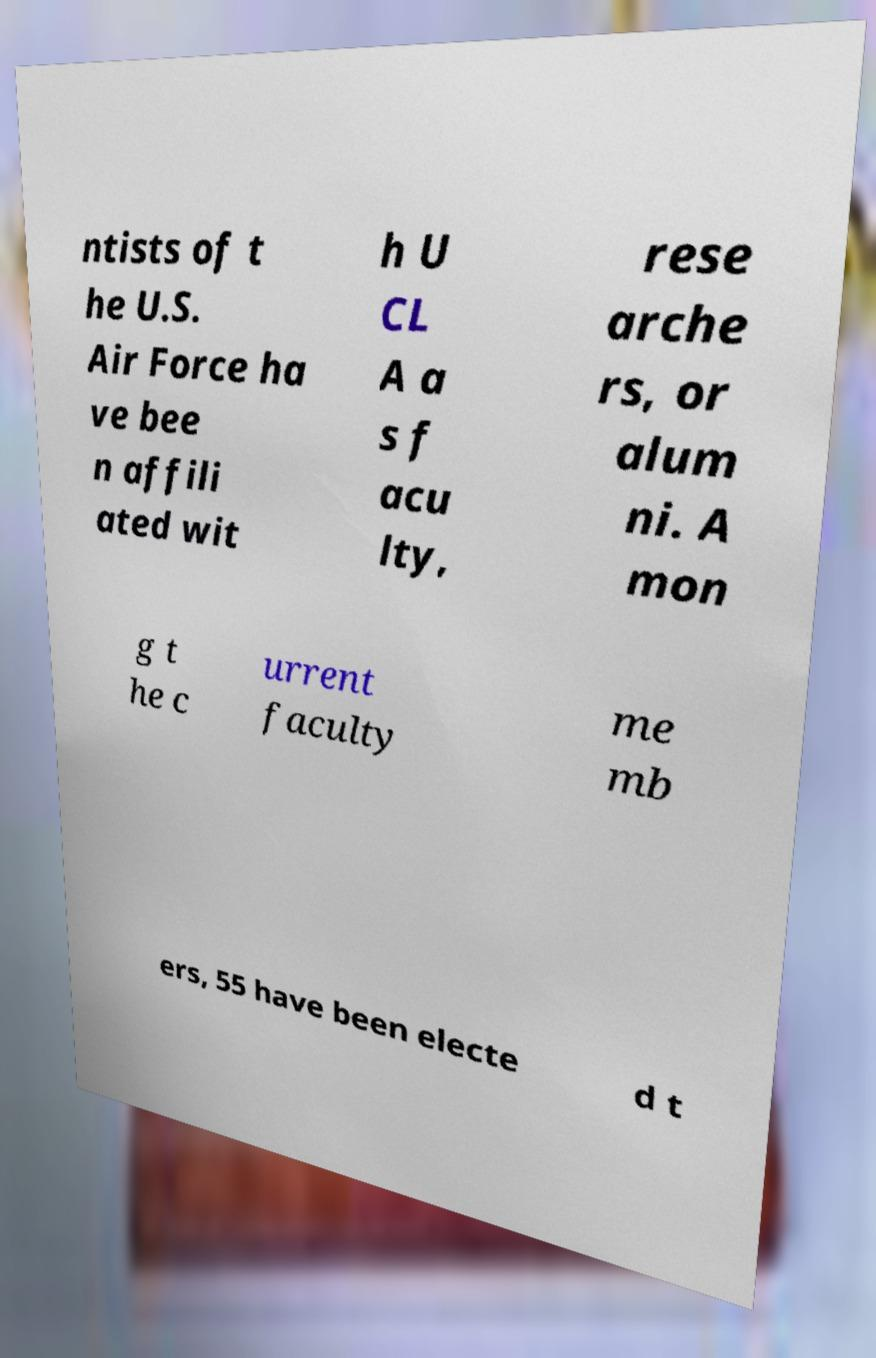Could you extract and type out the text from this image? ntists of t he U.S. Air Force ha ve bee n affili ated wit h U CL A a s f acu lty, rese arche rs, or alum ni. A mon g t he c urrent faculty me mb ers, 55 have been electe d t 